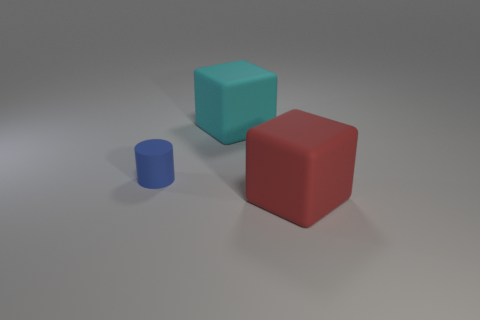There is a blue thing that is made of the same material as the big red block; what is its shape?
Make the answer very short. Cylinder. There is a large cyan cube behind the red rubber object; what is it made of?
Keep it short and to the point. Rubber. How big is the block that is to the left of the rubber block that is to the right of the large cyan block?
Offer a terse response. Large. Is the number of large blocks that are in front of the blue rubber cylinder greater than the number of tiny cyan blocks?
Your answer should be compact. Yes. Do the matte block that is to the right of the cyan block and the cyan rubber thing have the same size?
Your response must be concise. Yes. There is a matte object that is both on the left side of the large red block and on the right side of the small matte cylinder; what color is it?
Make the answer very short. Cyan. There is a red matte object that is the same size as the cyan matte object; what shape is it?
Your answer should be compact. Cube. Is the number of matte blocks that are behind the tiny blue matte object the same as the number of tiny matte objects?
Your response must be concise. Yes. There is a thing that is both to the right of the small matte cylinder and in front of the cyan matte thing; what is its size?
Ensure brevity in your answer.  Large. There is a tiny thing that is the same material as the large red object; what color is it?
Your answer should be compact. Blue. 